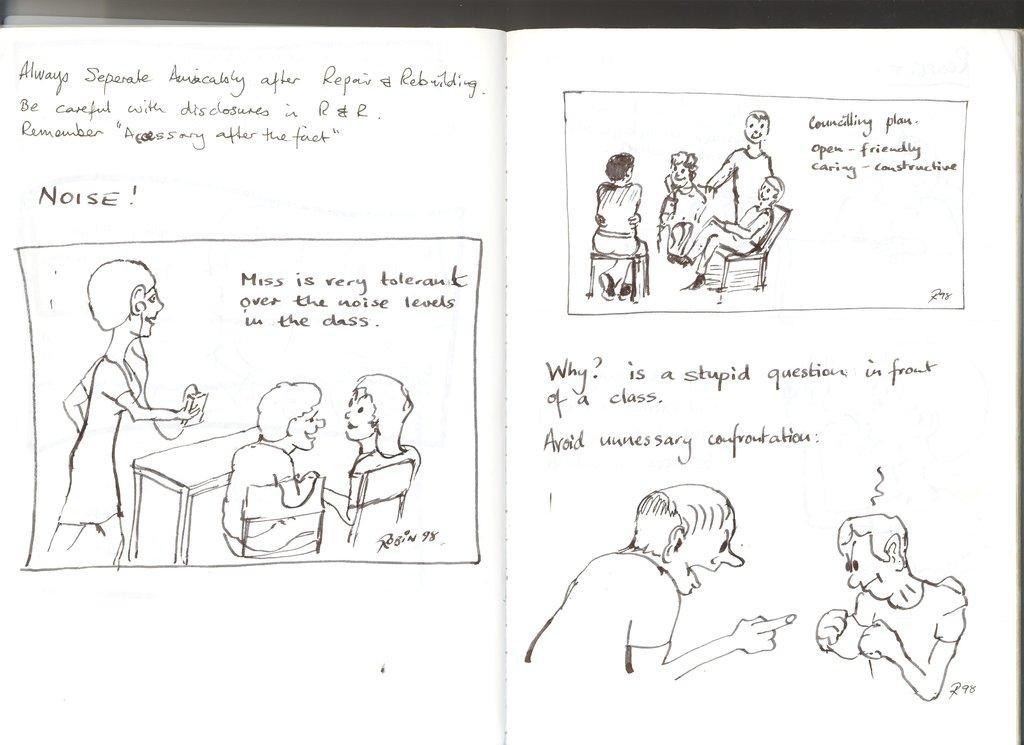In one or two sentences, can you explain what this image depicts? In this image we can see the cartoons and some text. 